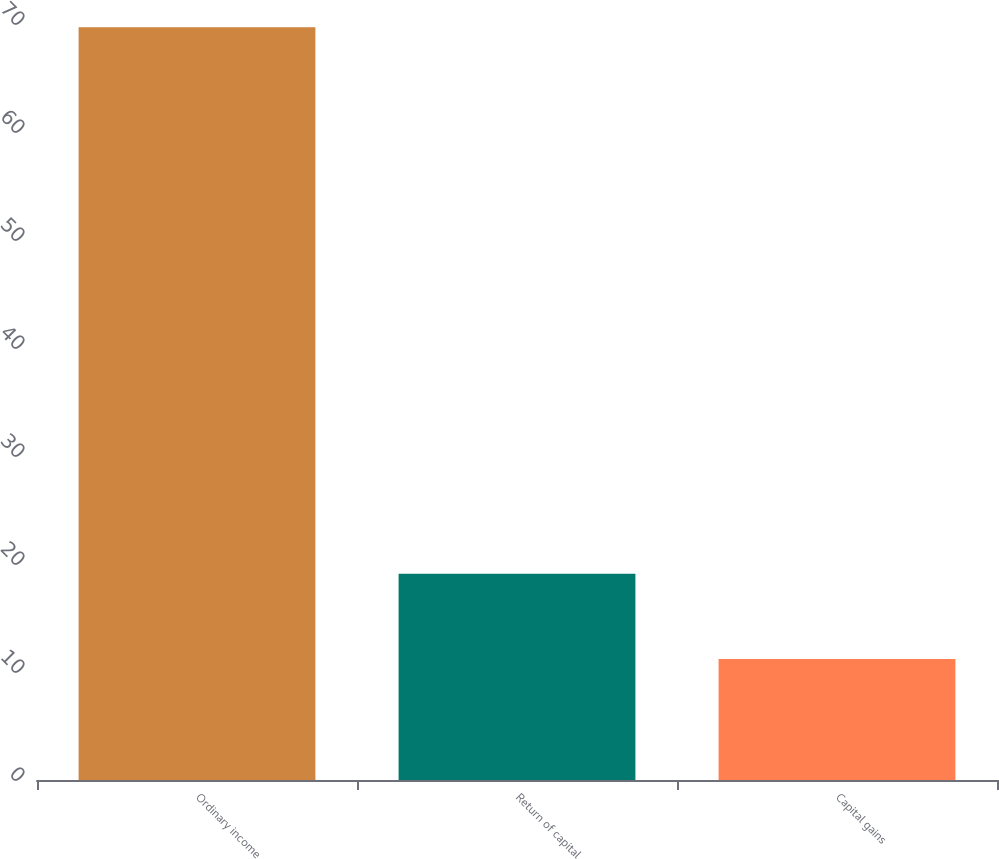Convert chart. <chart><loc_0><loc_0><loc_500><loc_500><bar_chart><fcel>Ordinary income<fcel>Return of capital<fcel>Capital gains<nl><fcel>69.7<fcel>19.1<fcel>11.2<nl></chart> 